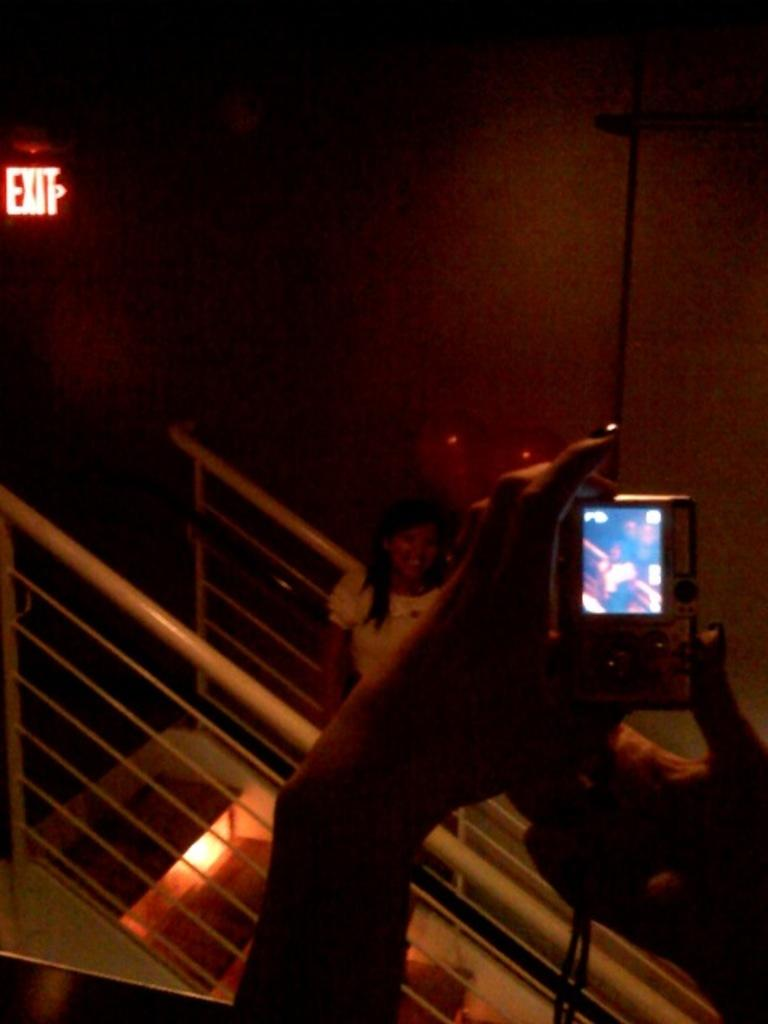<image>
Summarize the visual content of the image. A woman taking a picture of someone next to an exit sign 